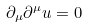Convert formula to latex. <formula><loc_0><loc_0><loc_500><loc_500>\partial _ { \mu } \partial ^ { \mu } u = 0</formula> 